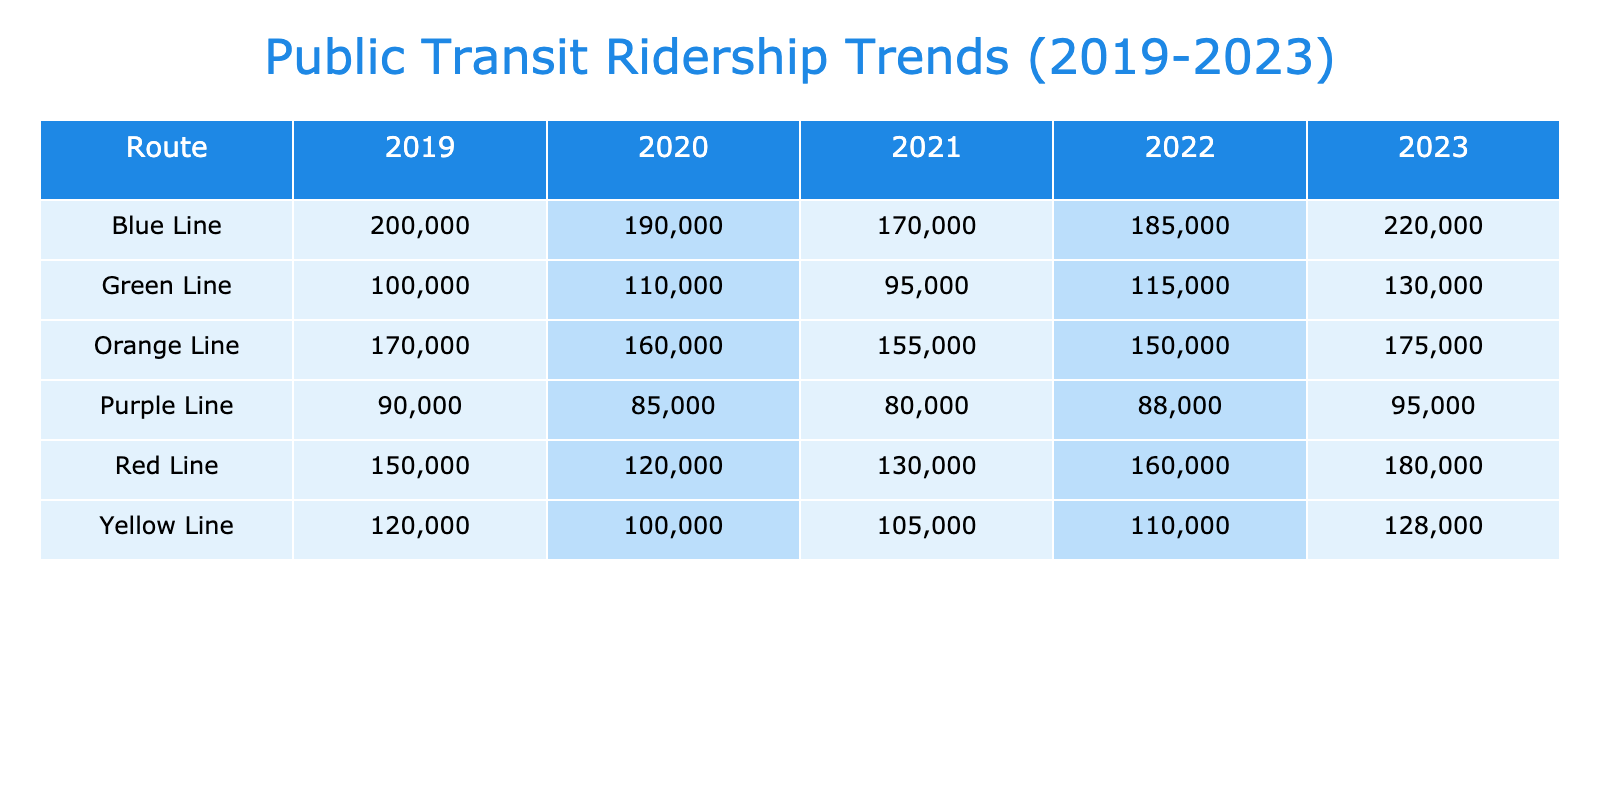What was the ridership for the Red Line in 2022? The table shows the ridership for the Red Line in the year 2022 to be 160,000.
Answer: 160000 Which route had the highest ridership in 2023? By examining the ridership values for 2023, the Blue Line has the highest ridership at 220,000.
Answer: Blue Line What was the percentage increase in ridership for the Yellow Line from 2019 to 2023? The ridership for the Yellow Line in 2019 was 120,000, and in 2023 it was 128,000. The increase is 128,000 - 120,000 = 8,000. The percentage increase is (8,000 / 120,000) * 100 = 6.67%.
Answer: 6.67% True or False: The Green Line had a higher ridership in 2023 compared to 2022. In 2022, the Green Line had a ridership of 115,000, and in 2023 it was 130,000. Since 130,000 is greater than 115,000, the statement is true.
Answer: True What was the average ridership across all routes in 2021? The ridership for each route in 2021 was: Red Line - 130,000, Blue Line - 170,000, Green Line - 95,000, Yellow Line - 105,000, Orange Line - 155,000, and Purple Line - 80,000. The total ridership is 130,000 + 170,000 + 95,000 + 105,000 + 155,000 + 80,000 = 735,000. There are 6 routes, so the average is 735,000 / 6 = 122,500.
Answer: 122500 Which route saw the largest decrease in ridership from 2019 to 2021? For 2019 to 2021, the routes and their changes are: Red Line (150,000 to 130,000) = -20,000, Blue Line (200,000 to 170,000) = -30,000, Green Line (100,000 to 95,000) = -5,000, Yellow Line (120,000 to 105,000) = -15,000, Orange Line (170,000 to 155,000) = -15,000, Purple Line (90,000 to 80,000) = -10,000. The Blue Line had the largest decrease of 30,000.
Answer: Blue Line What is the total ridership for the Orange Line over the last five years? The Orange Line's ridership for each year is: 2019 - 170,000, 2020 - 160,000, 2021 - 155,000, 2022 - 150,000, and 2023 - 175,000. Adding these together gives: 170,000 + 160,000 + 155,000 + 150,000 + 175,000 = 810,000.
Answer: 810000 What was the change in ridership for the Purple Line from 2020 to 2023? The Purple Line had a ridership of 85,000 in 2020 and 95,000 in 2023. The change is 95,000 - 85,000 = 10,000, indicating an increase.
Answer: 10000 